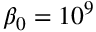<formula> <loc_0><loc_0><loc_500><loc_500>\beta _ { 0 } = 1 0 ^ { 9 }</formula> 